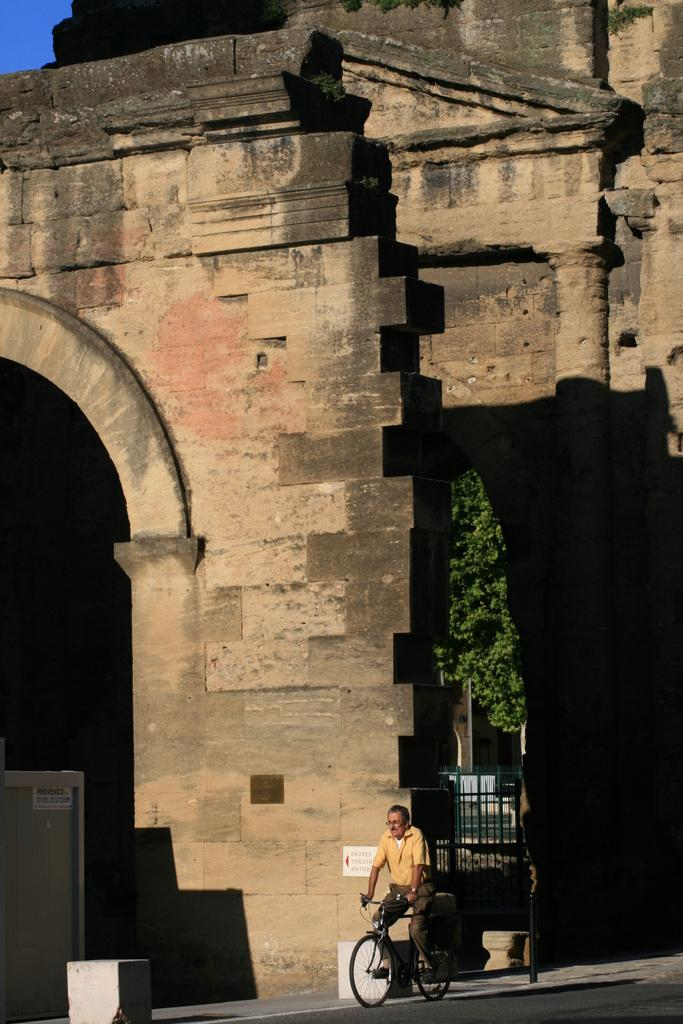What structure can be seen in the image? There is a stone arch or building in the image. What is the man in the image doing? The man is riding a bicycle in the image. What can be seen in the background of the image? There is a tree and a gate in the background of the image. How many matches does the man have in his pocket while riding the bicycle? There is no information about matches or the man's pocket in the image, so we cannot determine the number of matches. What type of tail is attached to the bicycle in the image? There is no tail present on the bicycle in the image. 